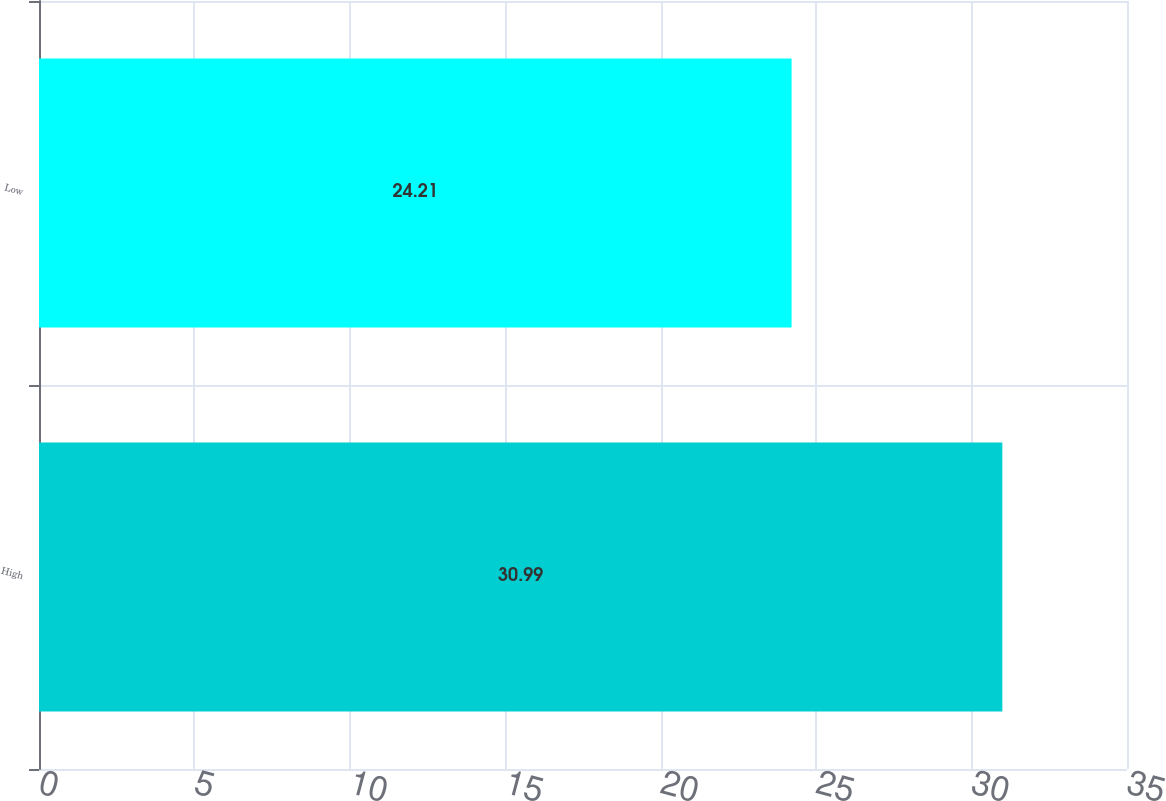Convert chart. <chart><loc_0><loc_0><loc_500><loc_500><bar_chart><fcel>High<fcel>Low<nl><fcel>30.99<fcel>24.21<nl></chart> 